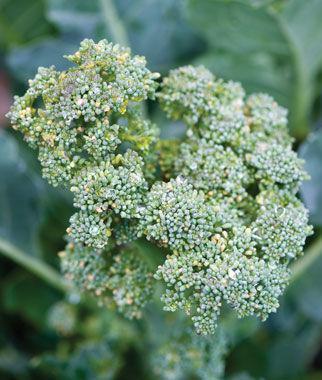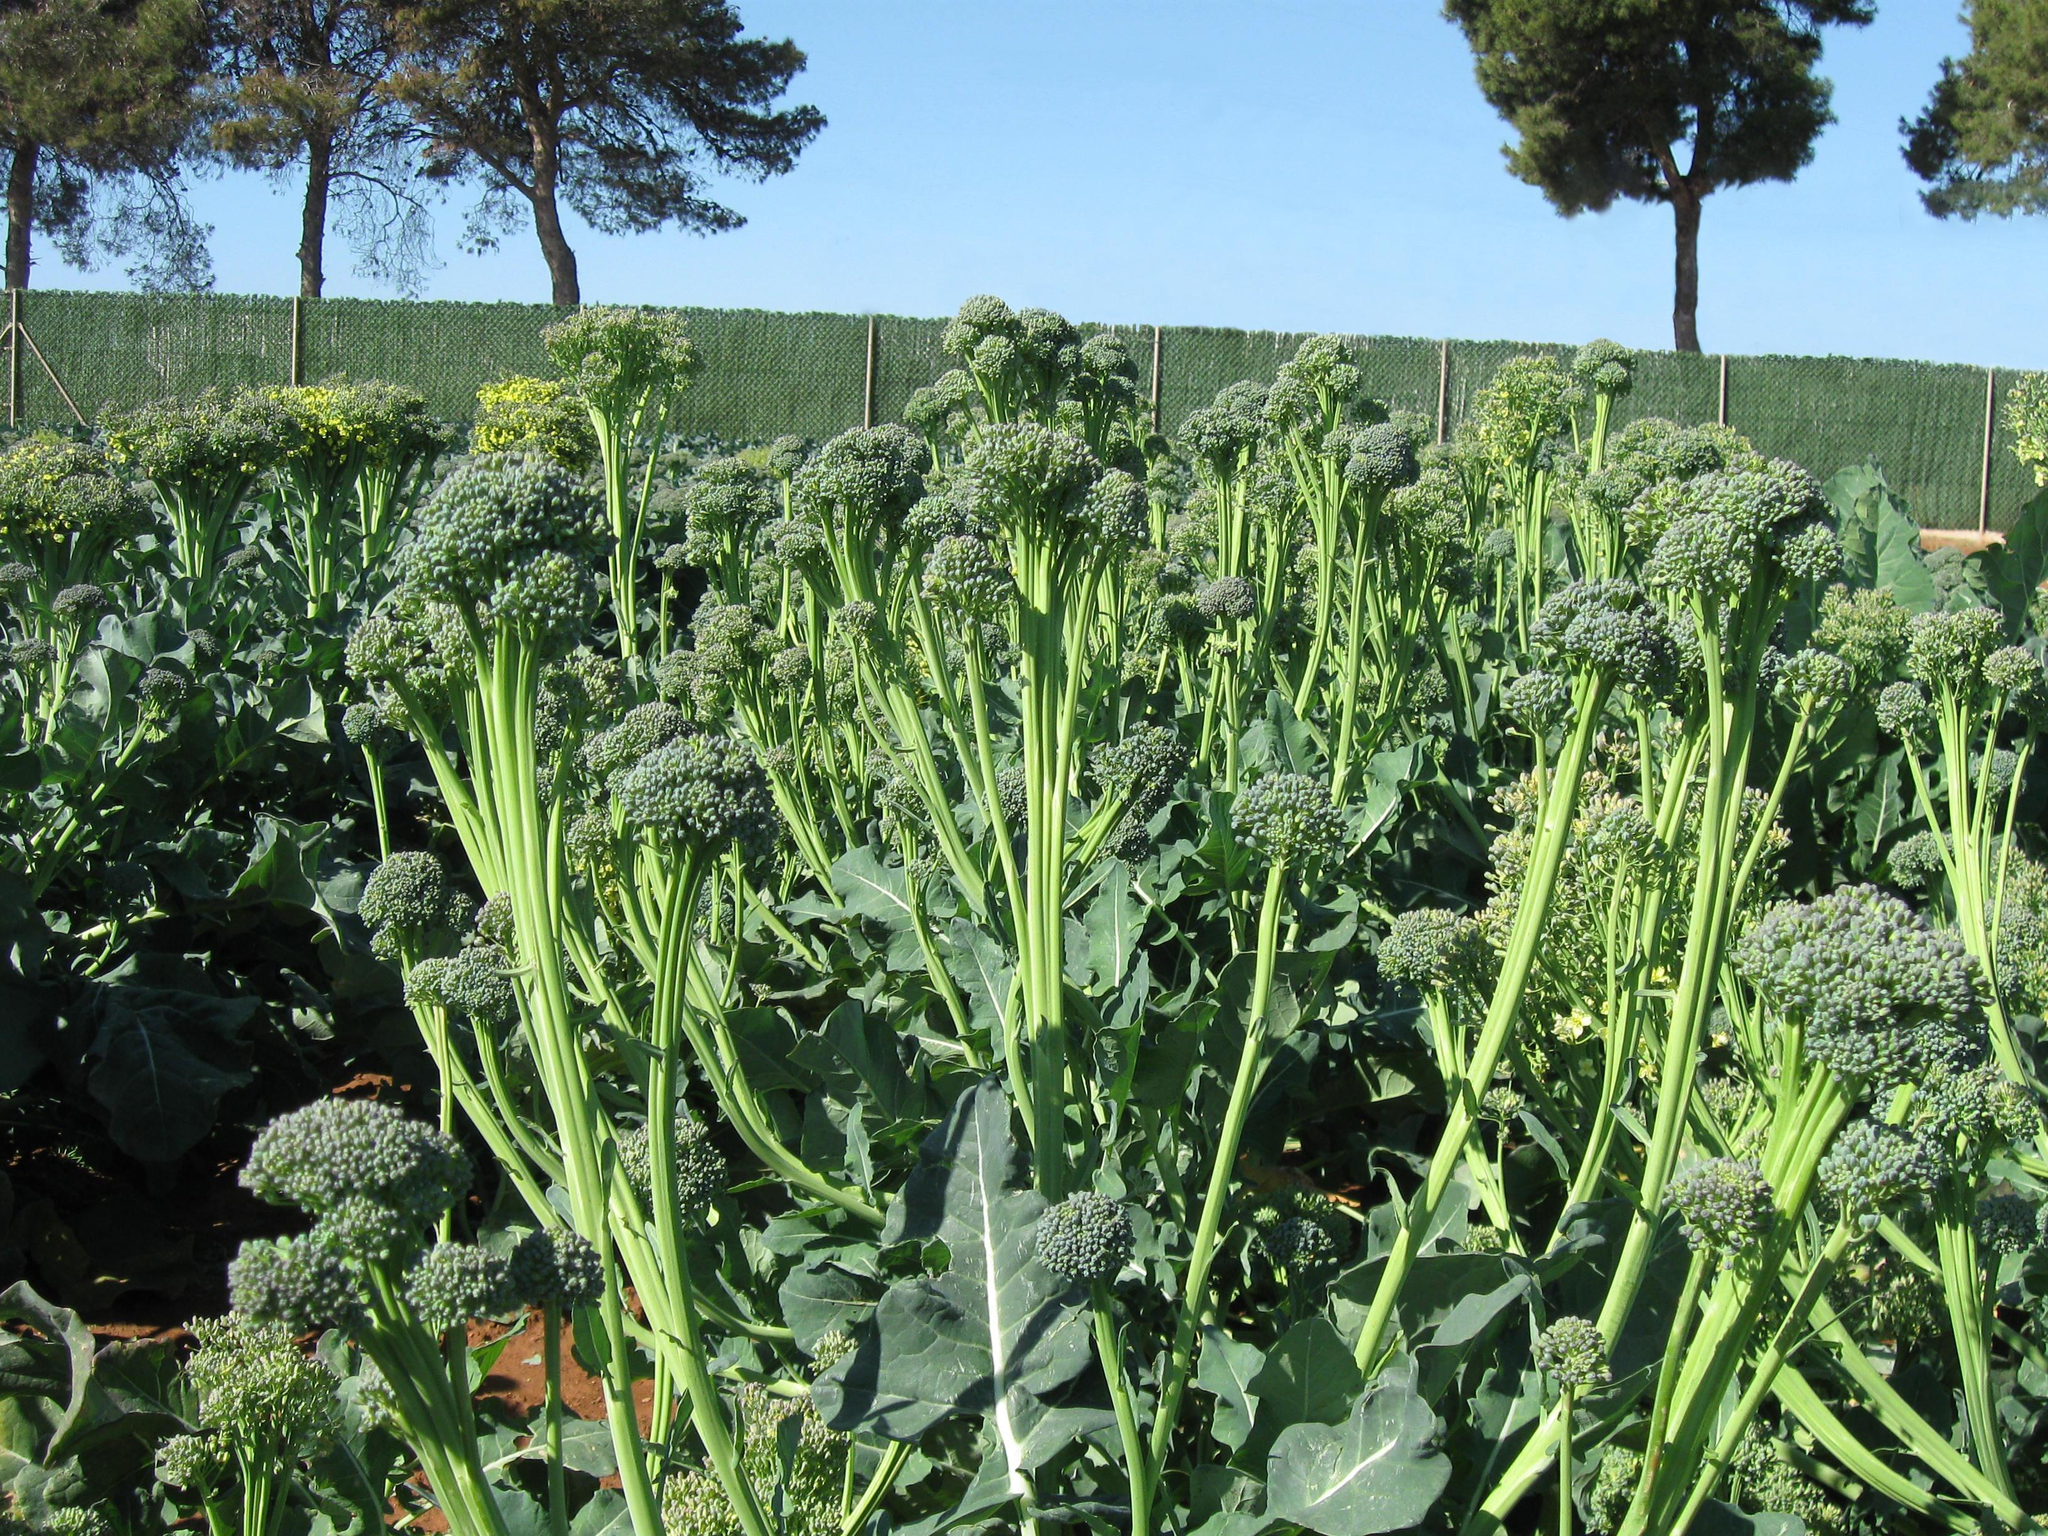The first image is the image on the left, the second image is the image on the right. Assess this claim about the two images: "The right image shows broccoli on a wooden surface.". Correct or not? Answer yes or no. No. The first image is the image on the left, the second image is the image on the right. Given the left and right images, does the statement "There is broccoli on a table." hold true? Answer yes or no. No. 